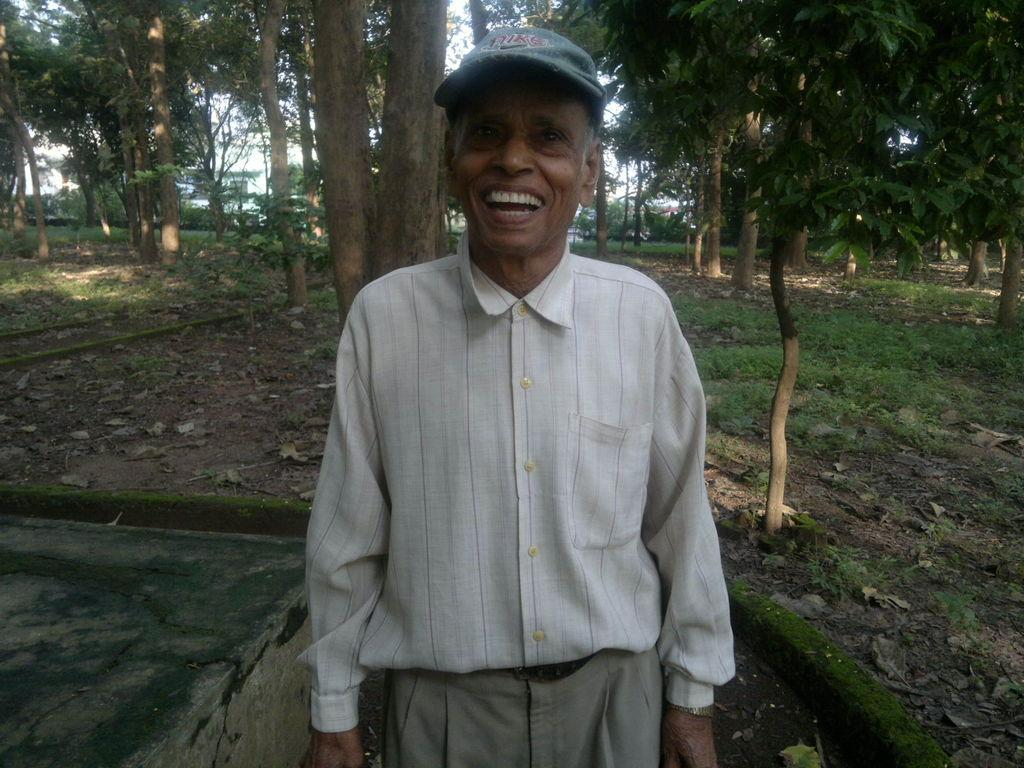What is the main subject in the foreground of the image? There is a person in the foreground of the image. What is the person wearing on their head? The person is wearing a cap. What can be seen in the background of the image? There are trees in the background of the image. What is the person's reaction to the disgusting voice in the image? There is no mention of a disgusting voice or any reaction in the image. 